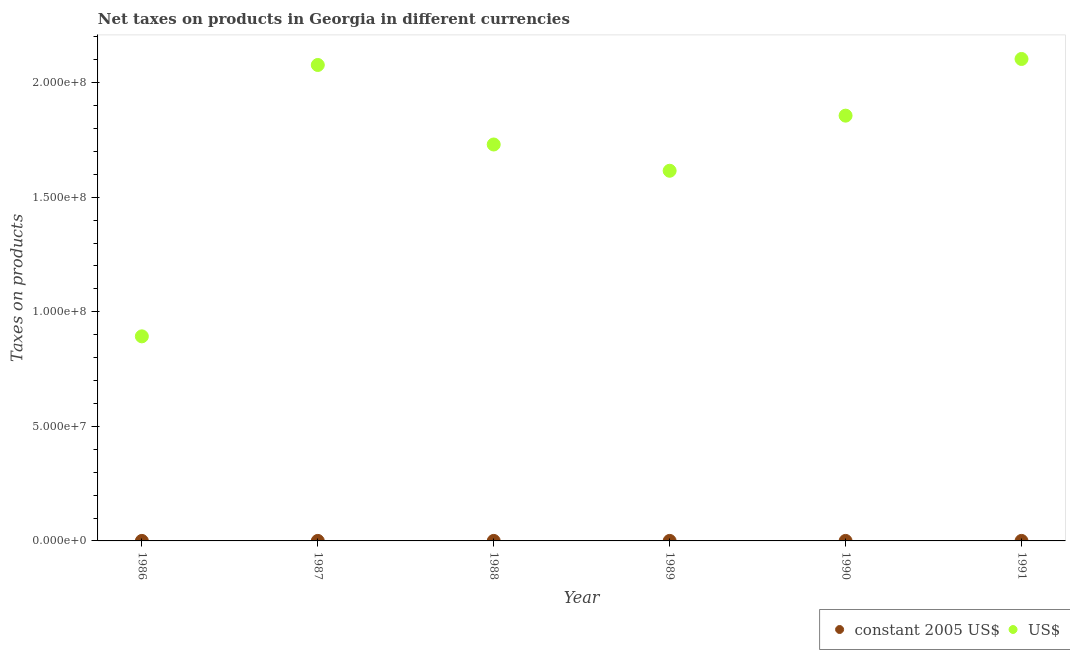Is the number of dotlines equal to the number of legend labels?
Provide a short and direct response. Yes. What is the net taxes in constant 2005 us$ in 1987?
Ensure brevity in your answer.  1000. Across all years, what is the maximum net taxes in constant 2005 us$?
Provide a succinct answer. 1400. Across all years, what is the minimum net taxes in us$?
Offer a very short reply. 8.93e+07. In which year was the net taxes in us$ maximum?
Your answer should be very brief. 1991. In which year was the net taxes in us$ minimum?
Keep it short and to the point. 1986. What is the total net taxes in us$ in the graph?
Offer a terse response. 1.03e+09. What is the difference between the net taxes in us$ in 1986 and that in 1990?
Make the answer very short. -9.63e+07. What is the difference between the net taxes in us$ in 1988 and the net taxes in constant 2005 us$ in 1986?
Make the answer very short. 1.73e+08. What is the average net taxes in us$ per year?
Offer a terse response. 1.71e+08. In the year 1988, what is the difference between the net taxes in us$ and net taxes in constant 2005 us$?
Offer a very short reply. 1.73e+08. What is the ratio of the net taxes in constant 2005 us$ in 1988 to that in 1991?
Your answer should be compact. 0.71. Is the difference between the net taxes in us$ in 1987 and 1991 greater than the difference between the net taxes in constant 2005 us$ in 1987 and 1991?
Your response must be concise. No. What is the difference between the highest and the second highest net taxes in constant 2005 us$?
Keep it short and to the point. 300. What is the difference between the highest and the lowest net taxes in constant 2005 us$?
Provide a succinct answer. 600. Is the net taxes in us$ strictly greater than the net taxes in constant 2005 us$ over the years?
Your answer should be compact. Yes. How many years are there in the graph?
Make the answer very short. 6. What is the difference between two consecutive major ticks on the Y-axis?
Offer a terse response. 5.00e+07. Does the graph contain grids?
Offer a terse response. No. Where does the legend appear in the graph?
Offer a terse response. Bottom right. How many legend labels are there?
Offer a terse response. 2. What is the title of the graph?
Make the answer very short. Net taxes on products in Georgia in different currencies. Does "Food and tobacco" appear as one of the legend labels in the graph?
Provide a short and direct response. No. What is the label or title of the X-axis?
Ensure brevity in your answer.  Year. What is the label or title of the Y-axis?
Provide a short and direct response. Taxes on products. What is the Taxes on products in constant 2005 US$ in 1986?
Give a very brief answer. 900. What is the Taxes on products of US$ in 1986?
Ensure brevity in your answer.  8.93e+07. What is the Taxes on products in constant 2005 US$ in 1987?
Ensure brevity in your answer.  1000. What is the Taxes on products in US$ in 1987?
Offer a very short reply. 2.08e+08. What is the Taxes on products in constant 2005 US$ in 1988?
Offer a terse response. 1000. What is the Taxes on products of US$ in 1988?
Offer a very short reply. 1.73e+08. What is the Taxes on products in constant 2005 US$ in 1989?
Provide a short and direct response. 1100. What is the Taxes on products in US$ in 1989?
Offer a terse response. 1.62e+08. What is the Taxes on products in constant 2005 US$ in 1990?
Provide a succinct answer. 800. What is the Taxes on products in US$ in 1990?
Keep it short and to the point. 1.86e+08. What is the Taxes on products of constant 2005 US$ in 1991?
Provide a succinct answer. 1400. What is the Taxes on products in US$ in 1991?
Ensure brevity in your answer.  2.10e+08. Across all years, what is the maximum Taxes on products of constant 2005 US$?
Offer a terse response. 1400. Across all years, what is the maximum Taxes on products in US$?
Make the answer very short. 2.10e+08. Across all years, what is the minimum Taxes on products of constant 2005 US$?
Offer a terse response. 800. Across all years, what is the minimum Taxes on products of US$?
Provide a succinct answer. 8.93e+07. What is the total Taxes on products of constant 2005 US$ in the graph?
Make the answer very short. 6200. What is the total Taxes on products of US$ in the graph?
Offer a very short reply. 1.03e+09. What is the difference between the Taxes on products in constant 2005 US$ in 1986 and that in 1987?
Offer a very short reply. -100. What is the difference between the Taxes on products in US$ in 1986 and that in 1987?
Offer a terse response. -1.18e+08. What is the difference between the Taxes on products in constant 2005 US$ in 1986 and that in 1988?
Make the answer very short. -100. What is the difference between the Taxes on products in US$ in 1986 and that in 1988?
Provide a succinct answer. -8.37e+07. What is the difference between the Taxes on products in constant 2005 US$ in 1986 and that in 1989?
Give a very brief answer. -200. What is the difference between the Taxes on products in US$ in 1986 and that in 1989?
Provide a succinct answer. -7.23e+07. What is the difference between the Taxes on products in US$ in 1986 and that in 1990?
Provide a short and direct response. -9.63e+07. What is the difference between the Taxes on products of constant 2005 US$ in 1986 and that in 1991?
Your answer should be compact. -500. What is the difference between the Taxes on products in US$ in 1986 and that in 1991?
Provide a succinct answer. -1.21e+08. What is the difference between the Taxes on products in US$ in 1987 and that in 1988?
Your response must be concise. 3.47e+07. What is the difference between the Taxes on products of constant 2005 US$ in 1987 and that in 1989?
Ensure brevity in your answer.  -100. What is the difference between the Taxes on products in US$ in 1987 and that in 1989?
Offer a very short reply. 4.62e+07. What is the difference between the Taxes on products in US$ in 1987 and that in 1990?
Make the answer very short. 2.21e+07. What is the difference between the Taxes on products of constant 2005 US$ in 1987 and that in 1991?
Offer a terse response. -400. What is the difference between the Taxes on products in US$ in 1987 and that in 1991?
Offer a very short reply. -2.62e+06. What is the difference between the Taxes on products of constant 2005 US$ in 1988 and that in 1989?
Keep it short and to the point. -100. What is the difference between the Taxes on products in US$ in 1988 and that in 1989?
Keep it short and to the point. 1.15e+07. What is the difference between the Taxes on products of constant 2005 US$ in 1988 and that in 1990?
Your answer should be very brief. 200. What is the difference between the Taxes on products of US$ in 1988 and that in 1990?
Give a very brief answer. -1.26e+07. What is the difference between the Taxes on products of constant 2005 US$ in 1988 and that in 1991?
Offer a very short reply. -400. What is the difference between the Taxes on products in US$ in 1988 and that in 1991?
Make the answer very short. -3.73e+07. What is the difference between the Taxes on products of constant 2005 US$ in 1989 and that in 1990?
Your answer should be compact. 300. What is the difference between the Taxes on products in US$ in 1989 and that in 1990?
Your response must be concise. -2.41e+07. What is the difference between the Taxes on products in constant 2005 US$ in 1989 and that in 1991?
Provide a short and direct response. -300. What is the difference between the Taxes on products in US$ in 1989 and that in 1991?
Give a very brief answer. -4.88e+07. What is the difference between the Taxes on products in constant 2005 US$ in 1990 and that in 1991?
Your response must be concise. -600. What is the difference between the Taxes on products in US$ in 1990 and that in 1991?
Your response must be concise. -2.47e+07. What is the difference between the Taxes on products of constant 2005 US$ in 1986 and the Taxes on products of US$ in 1987?
Make the answer very short. -2.08e+08. What is the difference between the Taxes on products of constant 2005 US$ in 1986 and the Taxes on products of US$ in 1988?
Make the answer very short. -1.73e+08. What is the difference between the Taxes on products of constant 2005 US$ in 1986 and the Taxes on products of US$ in 1989?
Your answer should be compact. -1.62e+08. What is the difference between the Taxes on products in constant 2005 US$ in 1986 and the Taxes on products in US$ in 1990?
Your response must be concise. -1.86e+08. What is the difference between the Taxes on products in constant 2005 US$ in 1986 and the Taxes on products in US$ in 1991?
Offer a very short reply. -2.10e+08. What is the difference between the Taxes on products in constant 2005 US$ in 1987 and the Taxes on products in US$ in 1988?
Your answer should be compact. -1.73e+08. What is the difference between the Taxes on products of constant 2005 US$ in 1987 and the Taxes on products of US$ in 1989?
Make the answer very short. -1.62e+08. What is the difference between the Taxes on products of constant 2005 US$ in 1987 and the Taxes on products of US$ in 1990?
Give a very brief answer. -1.86e+08. What is the difference between the Taxes on products in constant 2005 US$ in 1987 and the Taxes on products in US$ in 1991?
Offer a terse response. -2.10e+08. What is the difference between the Taxes on products in constant 2005 US$ in 1988 and the Taxes on products in US$ in 1989?
Your response must be concise. -1.62e+08. What is the difference between the Taxes on products in constant 2005 US$ in 1988 and the Taxes on products in US$ in 1990?
Provide a succinct answer. -1.86e+08. What is the difference between the Taxes on products of constant 2005 US$ in 1988 and the Taxes on products of US$ in 1991?
Give a very brief answer. -2.10e+08. What is the difference between the Taxes on products in constant 2005 US$ in 1989 and the Taxes on products in US$ in 1990?
Your answer should be very brief. -1.86e+08. What is the difference between the Taxes on products of constant 2005 US$ in 1989 and the Taxes on products of US$ in 1991?
Ensure brevity in your answer.  -2.10e+08. What is the difference between the Taxes on products of constant 2005 US$ in 1990 and the Taxes on products of US$ in 1991?
Provide a short and direct response. -2.10e+08. What is the average Taxes on products of constant 2005 US$ per year?
Provide a short and direct response. 1033.33. What is the average Taxes on products in US$ per year?
Make the answer very short. 1.71e+08. In the year 1986, what is the difference between the Taxes on products of constant 2005 US$ and Taxes on products of US$?
Provide a short and direct response. -8.93e+07. In the year 1987, what is the difference between the Taxes on products of constant 2005 US$ and Taxes on products of US$?
Your answer should be very brief. -2.08e+08. In the year 1988, what is the difference between the Taxes on products in constant 2005 US$ and Taxes on products in US$?
Provide a short and direct response. -1.73e+08. In the year 1989, what is the difference between the Taxes on products of constant 2005 US$ and Taxes on products of US$?
Provide a short and direct response. -1.62e+08. In the year 1990, what is the difference between the Taxes on products of constant 2005 US$ and Taxes on products of US$?
Provide a short and direct response. -1.86e+08. In the year 1991, what is the difference between the Taxes on products of constant 2005 US$ and Taxes on products of US$?
Provide a short and direct response. -2.10e+08. What is the ratio of the Taxes on products in constant 2005 US$ in 1986 to that in 1987?
Provide a succinct answer. 0.9. What is the ratio of the Taxes on products in US$ in 1986 to that in 1987?
Keep it short and to the point. 0.43. What is the ratio of the Taxes on products in US$ in 1986 to that in 1988?
Give a very brief answer. 0.52. What is the ratio of the Taxes on products in constant 2005 US$ in 1986 to that in 1989?
Your response must be concise. 0.82. What is the ratio of the Taxes on products of US$ in 1986 to that in 1989?
Your response must be concise. 0.55. What is the ratio of the Taxes on products in constant 2005 US$ in 1986 to that in 1990?
Provide a short and direct response. 1.12. What is the ratio of the Taxes on products of US$ in 1986 to that in 1990?
Ensure brevity in your answer.  0.48. What is the ratio of the Taxes on products in constant 2005 US$ in 1986 to that in 1991?
Your response must be concise. 0.64. What is the ratio of the Taxes on products of US$ in 1986 to that in 1991?
Make the answer very short. 0.42. What is the ratio of the Taxes on products of constant 2005 US$ in 1987 to that in 1988?
Give a very brief answer. 1. What is the ratio of the Taxes on products in US$ in 1987 to that in 1988?
Your answer should be compact. 1.2. What is the ratio of the Taxes on products of US$ in 1987 to that in 1989?
Offer a very short reply. 1.29. What is the ratio of the Taxes on products in constant 2005 US$ in 1987 to that in 1990?
Keep it short and to the point. 1.25. What is the ratio of the Taxes on products in US$ in 1987 to that in 1990?
Give a very brief answer. 1.12. What is the ratio of the Taxes on products of constant 2005 US$ in 1987 to that in 1991?
Ensure brevity in your answer.  0.71. What is the ratio of the Taxes on products of US$ in 1987 to that in 1991?
Give a very brief answer. 0.99. What is the ratio of the Taxes on products of constant 2005 US$ in 1988 to that in 1989?
Ensure brevity in your answer.  0.91. What is the ratio of the Taxes on products of US$ in 1988 to that in 1989?
Give a very brief answer. 1.07. What is the ratio of the Taxes on products in US$ in 1988 to that in 1990?
Ensure brevity in your answer.  0.93. What is the ratio of the Taxes on products in US$ in 1988 to that in 1991?
Provide a succinct answer. 0.82. What is the ratio of the Taxes on products in constant 2005 US$ in 1989 to that in 1990?
Provide a succinct answer. 1.38. What is the ratio of the Taxes on products in US$ in 1989 to that in 1990?
Offer a terse response. 0.87. What is the ratio of the Taxes on products of constant 2005 US$ in 1989 to that in 1991?
Provide a short and direct response. 0.79. What is the ratio of the Taxes on products in US$ in 1989 to that in 1991?
Provide a succinct answer. 0.77. What is the ratio of the Taxes on products in constant 2005 US$ in 1990 to that in 1991?
Provide a short and direct response. 0.57. What is the ratio of the Taxes on products in US$ in 1990 to that in 1991?
Ensure brevity in your answer.  0.88. What is the difference between the highest and the second highest Taxes on products in constant 2005 US$?
Offer a very short reply. 300. What is the difference between the highest and the second highest Taxes on products in US$?
Your answer should be very brief. 2.62e+06. What is the difference between the highest and the lowest Taxes on products of constant 2005 US$?
Provide a short and direct response. 600. What is the difference between the highest and the lowest Taxes on products of US$?
Make the answer very short. 1.21e+08. 